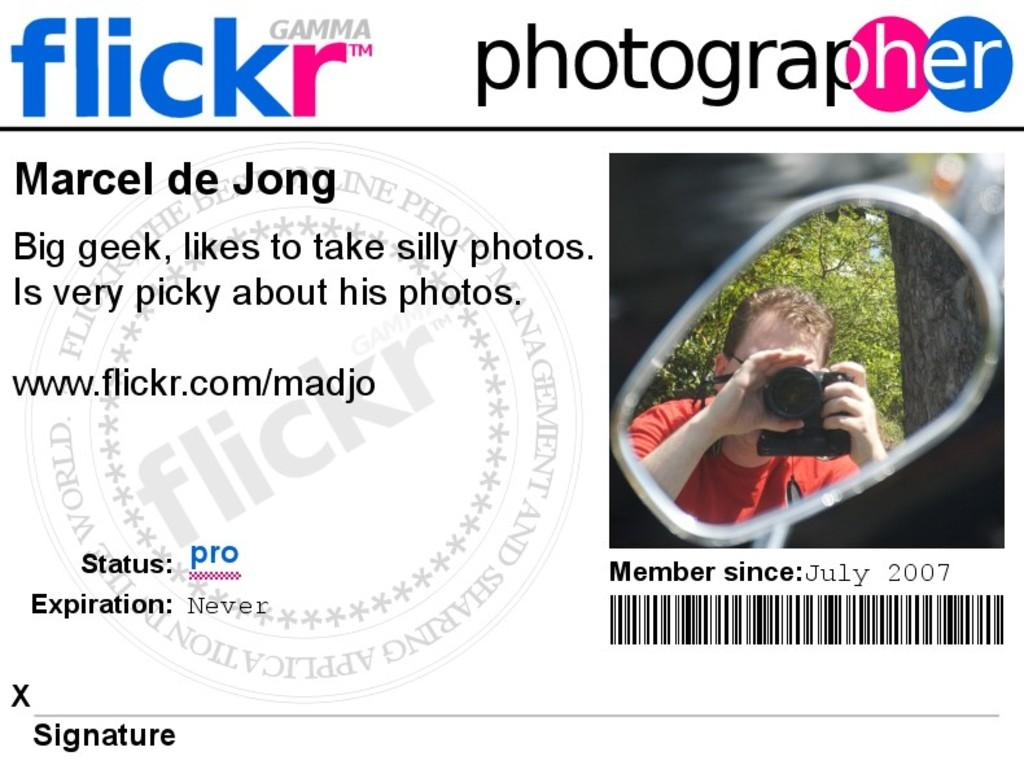What is featured on the poster in the image? The poster in the image contains text, a barcode, and an image. Can you describe the image on the poster? Unfortunately, the specific image on the poster cannot be described with the information provided. What is the purpose of the barcode on the poster? The purpose of the barcode on the poster is likely for tracking or identification purposes. What type of paint is being used to create the drum sound in the image? There is no paint or drum sound present in the image; it features a poster with text, a barcode, and an image. 